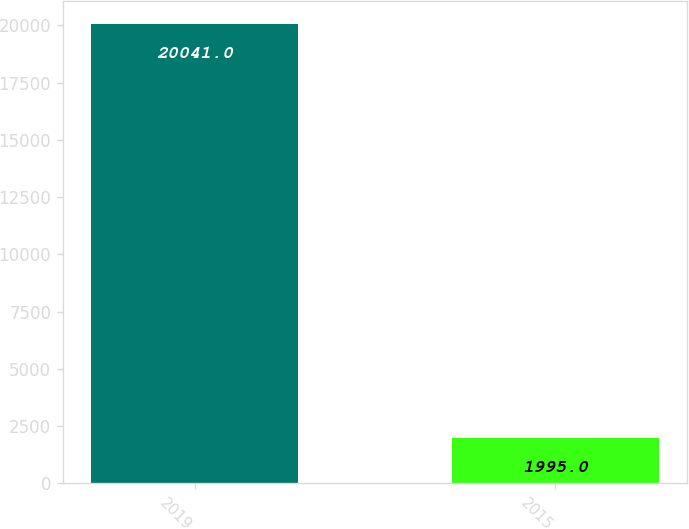Convert chart to OTSL. <chart><loc_0><loc_0><loc_500><loc_500><bar_chart><fcel>2019<fcel>2015<nl><fcel>20041<fcel>1995<nl></chart> 